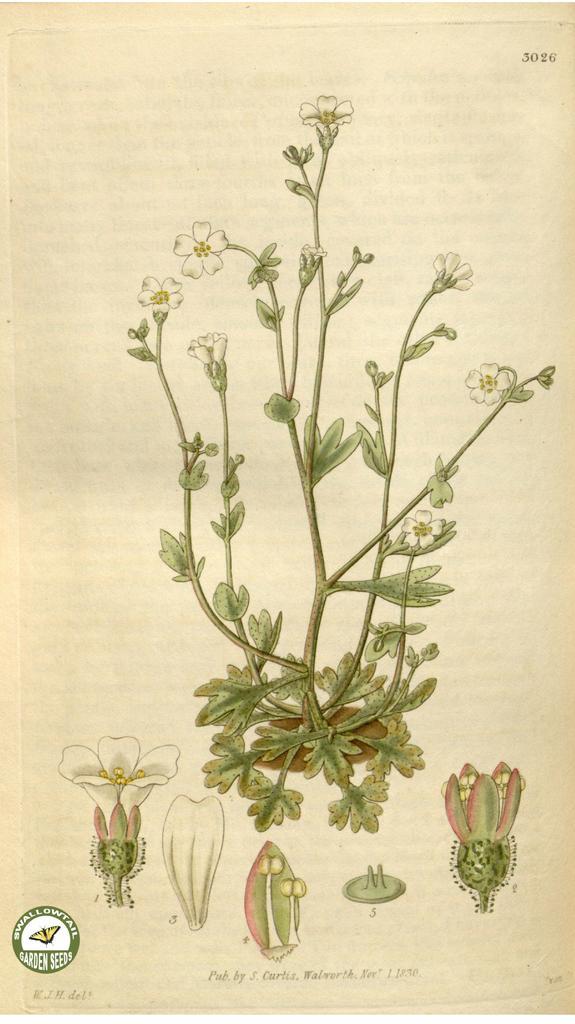Can you describe this image briefly? In this picture I can observe a diagram of a plant in the paper. The paper is in cream color. The plant is in green color. 